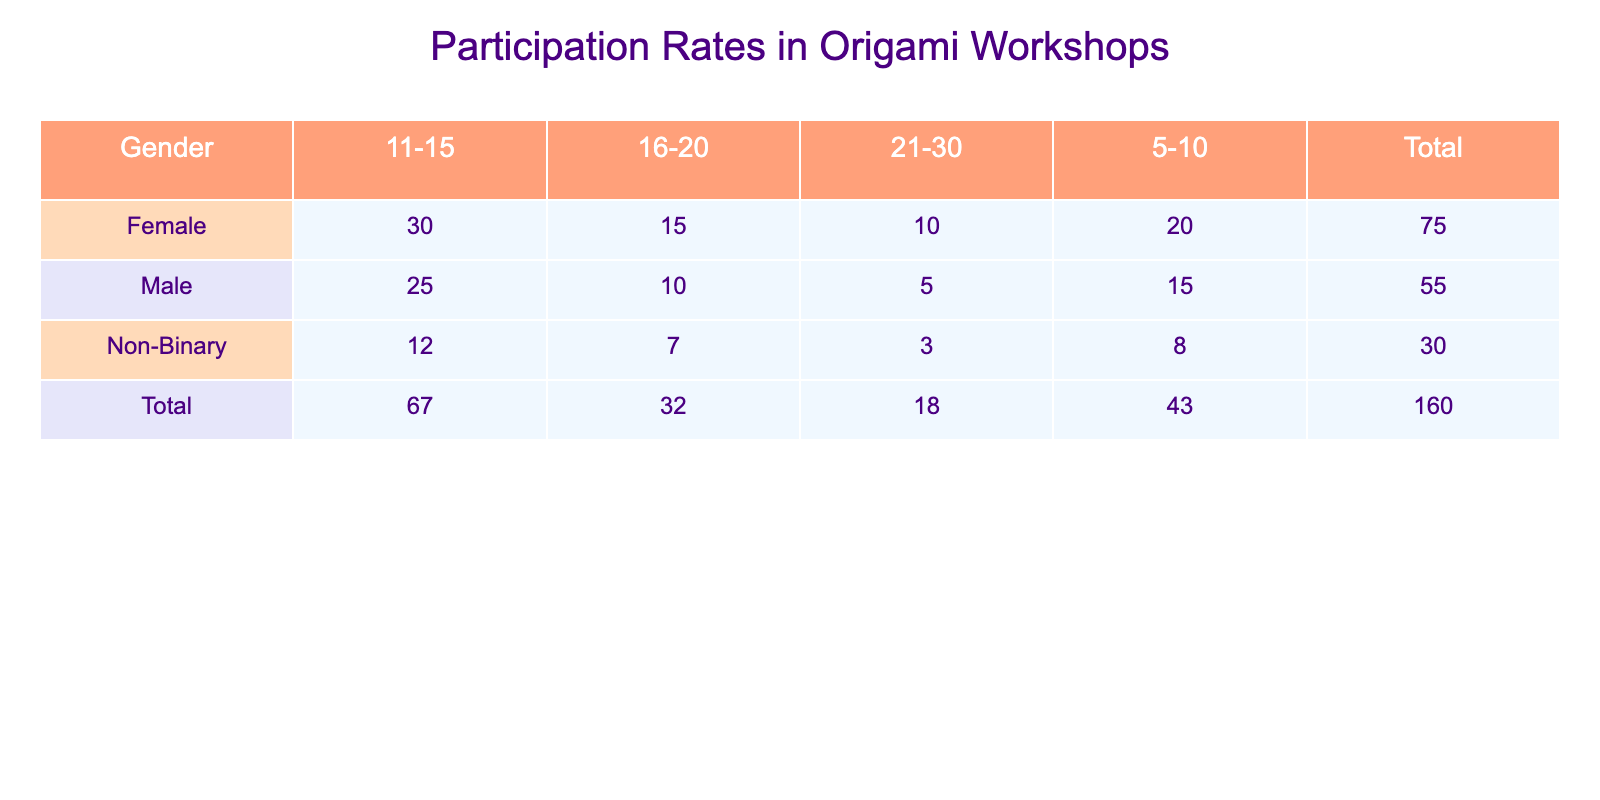What is the total number of participants in origami workshops for the age group 11-15? To find this, look at the column for the age group 11-15. The total for males is 25, females is 30, and non-binary is 12. Adding these values together gives 25 + 30 + 12 = 67.
Answer: 67 Which gender had the highest participation in the age group 5-10? Check the 5-10 row for each gender. Males have 15 participants, females have 20, and non-binary have 8. The maximum value is 20, which belongs to females.
Answer: Female Is the total number of male participants greater than the total number of female participants? First, sum the males: 15 + 25 + 10 + 5 = 55. Now sum the females: 20 + 30 + 15 + 10 = 75. Since 55 is less than 75, the statement is false.
Answer: No What is the average number of participants for the non-binary gender across all age groups? To find the average, sum the non-binary participants: 8 + 12 + 7 + 3 = 30. There are 4 age groups, so we calculate the average as 30 / 4 = 7.5.
Answer: 7.5 How many more females participated in the age group 11-15 than non-binary participants in the same age group? Participants for females in 11-15 is 30, and for non-binary it is 12. To find the difference, subtract non-binary from female: 30 - 12 = 18.
Answer: 18 Is there any age group where non-binary participants are more than males? Inspect the rows. Non-binary participants are 8, 12, 7, and 3 for age groups 5-10, 11-15, 16-20, and 21-30 respectively, while males have 15, 25, 10, and 5. There’s no age group where non-binary exceeds males.
Answer: No What percentage of total participants are female? Sum total participants: Males 55 + Females 75 + Non-binary 30 = 160. Now, female percentage: (75 / 160) * 100 = 46.875%.
Answer: 46.88% Among all participants, which age group has the least attendance and how many were in that group? Scan through all age groups: 5-10 (43), 11-15 (67), 16-20 (32), 21-30 (18). The least is in 21-30 with 18 participants.
Answer: 21-30, 18 